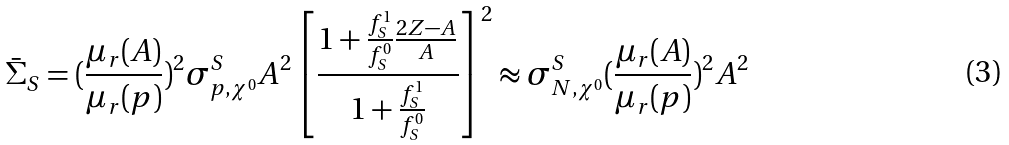Convert formula to latex. <formula><loc_0><loc_0><loc_500><loc_500>\bar { \Sigma } _ { S } = ( \frac { \mu _ { r } ( A ) } { \mu _ { r } ( p ) } ) ^ { 2 } \sigma ^ { S } _ { p , \chi ^ { 0 } } A ^ { 2 } \left [ \frac { 1 + \frac { f ^ { 1 } _ { S } } { f ^ { 0 } _ { S } } \frac { 2 Z - A } { A } } { 1 + \frac { f ^ { 1 } _ { S } } { f ^ { 0 } _ { S } } } \right ] ^ { 2 } \approx \sigma ^ { S } _ { N , \chi ^ { 0 } } ( \frac { \mu _ { r } ( A ) } { \mu _ { r } ( p ) } ) ^ { 2 } A ^ { 2 }</formula> 